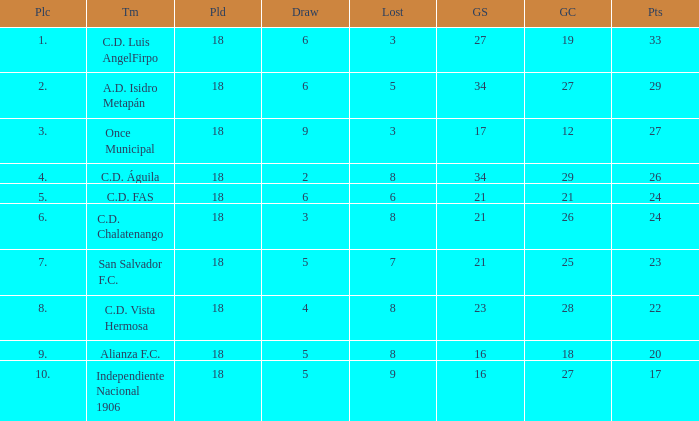What is the lowest amount of goals scored that has more than 19 goal conceded and played less than 18? None. 